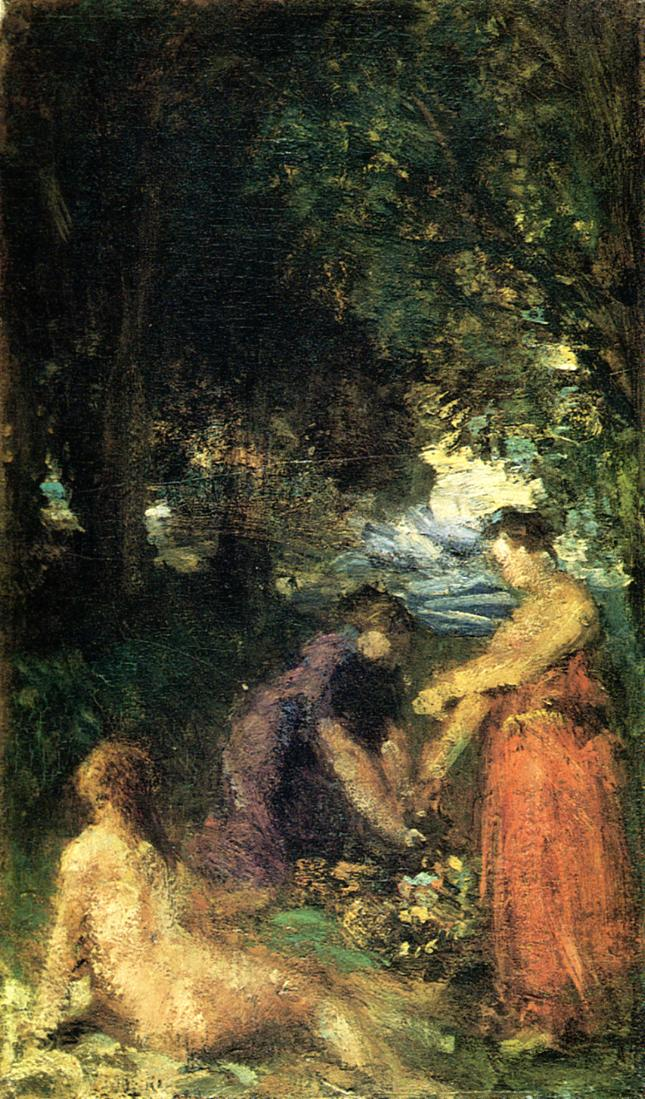Could you imagine a backstory for one of the figures in the painting? Certainly, one might envision the figure in red as a nurturing character, perhaps a caretaker of the natural world around her, sharing her knowledge of the flora with her companions. Her posture and interaction with the environment suggest a story of connection and guidance. How might the lighting in the painting add to the narrative? The dappling of sunlight through the leaves creates a sense of temporal specificity, like a brief moment captured in time. It might suggest the passing of hours in this tranquil retreat, emphasizing the fleeting nature of such peaceful experiences. 